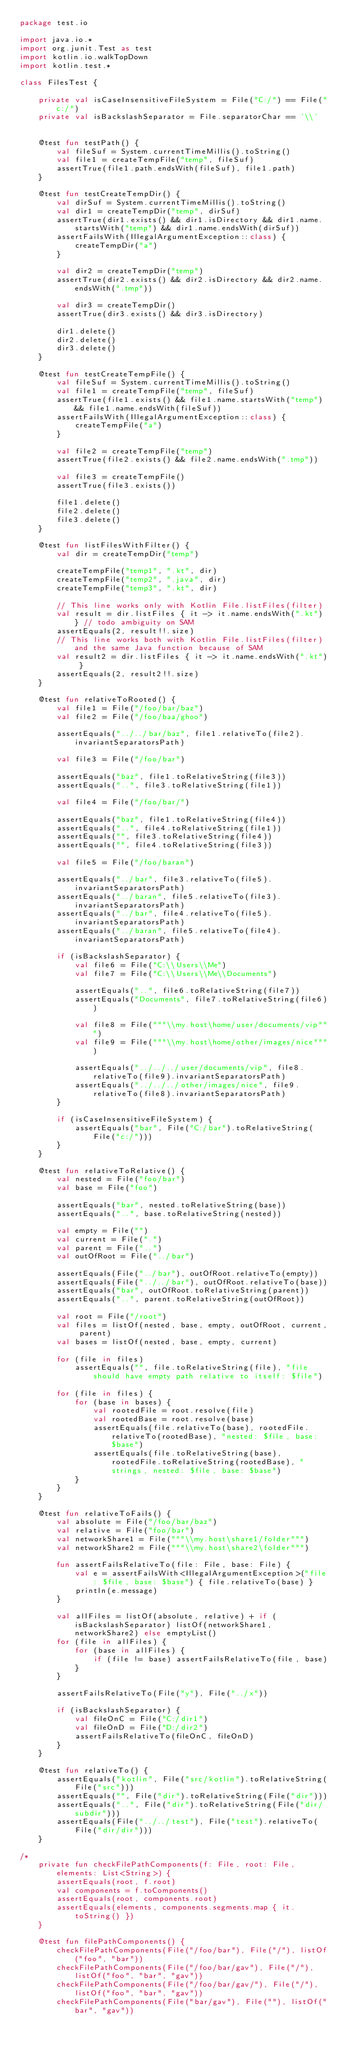Convert code to text. <code><loc_0><loc_0><loc_500><loc_500><_Kotlin_>package test.io

import java.io.*
import org.junit.Test as test
import kotlin.io.walkTopDown
import kotlin.test.*

class FilesTest {

    private val isCaseInsensitiveFileSystem = File("C:/") == File("c:/")
    private val isBackslashSeparator = File.separatorChar == '\\'


    @test fun testPath() {
        val fileSuf = System.currentTimeMillis().toString()
        val file1 = createTempFile("temp", fileSuf)
        assertTrue(file1.path.endsWith(fileSuf), file1.path)
    }

    @test fun testCreateTempDir() {
        val dirSuf = System.currentTimeMillis().toString()
        val dir1 = createTempDir("temp", dirSuf)
        assertTrue(dir1.exists() && dir1.isDirectory && dir1.name.startsWith("temp") && dir1.name.endsWith(dirSuf))
        assertFailsWith(IllegalArgumentException::class) {
            createTempDir("a")
        }

        val dir2 = createTempDir("temp")
        assertTrue(dir2.exists() && dir2.isDirectory && dir2.name.endsWith(".tmp"))

        val dir3 = createTempDir()
        assertTrue(dir3.exists() && dir3.isDirectory)

        dir1.delete()
        dir2.delete()
        dir3.delete()
    }

    @test fun testCreateTempFile() {
        val fileSuf = System.currentTimeMillis().toString()
        val file1 = createTempFile("temp", fileSuf)
        assertTrue(file1.exists() && file1.name.startsWith("temp") && file1.name.endsWith(fileSuf))
        assertFailsWith(IllegalArgumentException::class) {
            createTempFile("a")
        }

        val file2 = createTempFile("temp")
        assertTrue(file2.exists() && file2.name.endsWith(".tmp"))

        val file3 = createTempFile()
        assertTrue(file3.exists())

        file1.delete()
        file2.delete()
        file3.delete()
    }

    @test fun listFilesWithFilter() {
        val dir = createTempDir("temp")

        createTempFile("temp1", ".kt", dir)
        createTempFile("temp2", ".java", dir)
        createTempFile("temp3", ".kt", dir)

        // This line works only with Kotlin File.listFiles(filter)
        val result = dir.listFiles { it -> it.name.endsWith(".kt") } // todo ambiguity on SAM
        assertEquals(2, result!!.size)
        // This line works both with Kotlin File.listFiles(filter) and the same Java function because of SAM
        val result2 = dir.listFiles { it -> it.name.endsWith(".kt") }
        assertEquals(2, result2!!.size)
    }

    @test fun relativeToRooted() {
        val file1 = File("/foo/bar/baz")
        val file2 = File("/foo/baa/ghoo")

        assertEquals("../../bar/baz", file1.relativeTo(file2).invariantSeparatorsPath)

        val file3 = File("/foo/bar")

        assertEquals("baz", file1.toRelativeString(file3))
        assertEquals("..", file3.toRelativeString(file1))

        val file4 = File("/foo/bar/")

        assertEquals("baz", file1.toRelativeString(file4))
        assertEquals("..", file4.toRelativeString(file1))
        assertEquals("", file3.toRelativeString(file4))
        assertEquals("", file4.toRelativeString(file3))

        val file5 = File("/foo/baran")

        assertEquals("../bar", file3.relativeTo(file5).invariantSeparatorsPath)
        assertEquals("../baran", file5.relativeTo(file3).invariantSeparatorsPath)
        assertEquals("../bar", file4.relativeTo(file5).invariantSeparatorsPath)
        assertEquals("../baran", file5.relativeTo(file4).invariantSeparatorsPath)

        if (isBackslashSeparator) {
            val file6 = File("C:\\Users\\Me")
            val file7 = File("C:\\Users\\Me\\Documents")

            assertEquals("..", file6.toRelativeString(file7))
            assertEquals("Documents", file7.toRelativeString(file6))

            val file8 = File("""\\my.host\home/user/documents/vip""")
            val file9 = File("""\\my.host\home/other/images/nice""")

            assertEquals("../../../user/documents/vip", file8.relativeTo(file9).invariantSeparatorsPath)
            assertEquals("../../../other/images/nice", file9.relativeTo(file8).invariantSeparatorsPath)
        }

        if (isCaseInsensitiveFileSystem) {
            assertEquals("bar", File("C:/bar").toRelativeString(File("c:/")))
        }
    }

    @test fun relativeToRelative() {
        val nested = File("foo/bar")
        val base = File("foo")

        assertEquals("bar", nested.toRelativeString(base))
        assertEquals("..", base.toRelativeString(nested))

        val empty = File("")
        val current = File(".")
        val parent = File("..")
        val outOfRoot = File("../bar")

        assertEquals(File("../bar"), outOfRoot.relativeTo(empty))
        assertEquals(File("../../bar"), outOfRoot.relativeTo(base))
        assertEquals("bar", outOfRoot.toRelativeString(parent))
        assertEquals("..", parent.toRelativeString(outOfRoot))

        val root = File("/root")
        val files = listOf(nested, base, empty, outOfRoot, current, parent)
        val bases = listOf(nested, base, empty, current)

        for (file in files)
            assertEquals("", file.toRelativeString(file), "file should have empty path relative to itself: $file")

        for (file in files) {
            for (base in bases) {
                val rootedFile = root.resolve(file)
                val rootedBase = root.resolve(base)
                assertEquals(file.relativeTo(base), rootedFile.relativeTo(rootedBase), "nested: $file, base: $base")
                assertEquals(file.toRelativeString(base), rootedFile.toRelativeString(rootedBase), "strings, nested: $file, base: $base")
            }
        }
    }

    @test fun relativeToFails() {
        val absolute = File("/foo/bar/baz")
        val relative = File("foo/bar")
        val networkShare1 = File("""\\my.host\share1/folder""")
        val networkShare2 = File("""\\my.host\share2\folder""")

        fun assertFailsRelativeTo(file: File, base: File) {
            val e = assertFailsWith<IllegalArgumentException>("file: $file, base: $base") { file.relativeTo(base) }
            println(e.message)
        }

        val allFiles = listOf(absolute, relative) + if (isBackslashSeparator) listOf(networkShare1, networkShare2) else emptyList()
        for (file in allFiles) {
            for (base in allFiles) {
                if (file != base) assertFailsRelativeTo(file, base)
            }
        }

        assertFailsRelativeTo(File("y"), File("../x"))

        if (isBackslashSeparator) {
            val fileOnC = File("C:/dir1")
            val fileOnD = File("D:/dir2")
            assertFailsRelativeTo(fileOnC, fileOnD)
        }
    }

    @test fun relativeTo() {
        assertEquals("kotlin", File("src/kotlin").toRelativeString(File("src")))
        assertEquals("", File("dir").toRelativeString(File("dir")))
        assertEquals("..", File("dir").toRelativeString(File("dir/subdir")))
        assertEquals(File("../../test"), File("test").relativeTo(File("dir/dir")))
    }

/*
    private fun checkFilePathComponents(f: File, root: File, elements: List<String>) {
        assertEquals(root, f.root)
        val components = f.toComponents()
        assertEquals(root, components.root)
        assertEquals(elements, components.segments.map { it.toString() })
    }

    @test fun filePathComponents() {
        checkFilePathComponents(File("/foo/bar"), File("/"), listOf("foo", "bar"))
        checkFilePathComponents(File("/foo/bar/gav"), File("/"), listOf("foo", "bar", "gav"))
        checkFilePathComponents(File("/foo/bar/gav/"), File("/"), listOf("foo", "bar", "gav"))
        checkFilePathComponents(File("bar/gav"), File(""), listOf("bar", "gav"))</code> 